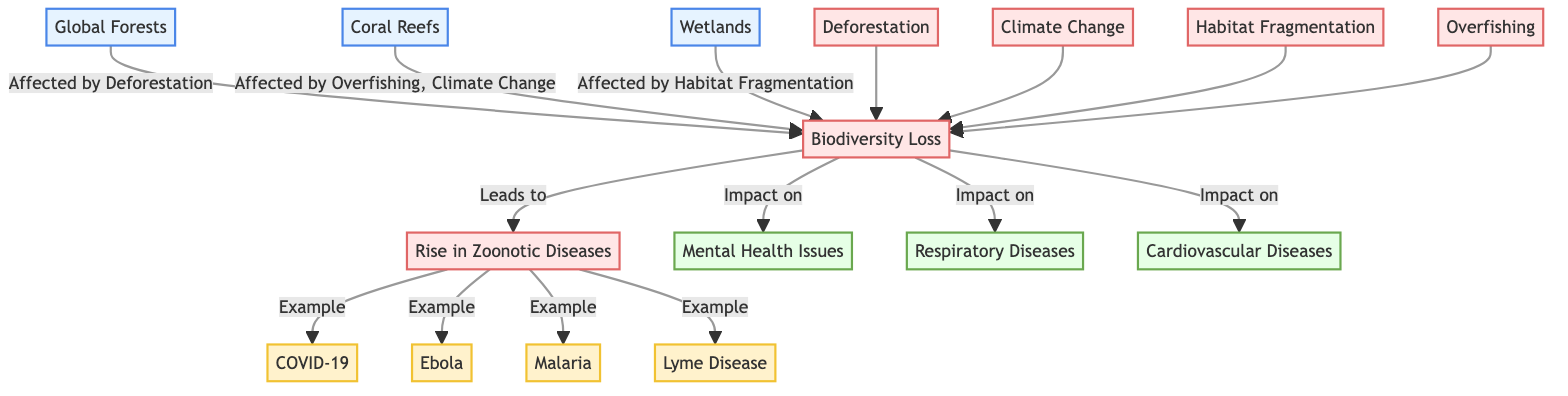What ecosystems are affected by deforestation? In the diagram, Global Forests is directly connected to Biodiversity Loss with the label "Affected by Deforestation". This indicates that Global Forests are one of the ecosystems impacted by deforestation.
Answer: Global Forests How many diseases are examples of zoonotic diseases in the diagram? The diagram lists four specific examples of zoonotic diseases connected to the Zoonotic Diseases node: COVID-19, Ebola, Malaria, and Lyme Disease. Counting these, we find there are four examples.
Answer: 4 Which ecosystem is affected by habitat fragmentation? The diagram shows a connection from Wetlands to Biodiversity Loss with the label "Affected by Habitat Fragmentation". This indicates that Wetlands is the ecosystem affected by habitat fragmentation.
Answer: Wetlands What is the impact of biodiversity loss on mental health? The diagram indicates a direct connection from Biodiversity Loss to Mental Health Issues with the label "Impact on". This shows that biodiversity loss has an effect on mental health.
Answer: Mental Health Issues Which disease is listed as an example of a zoonotic disease along with malaria? Among the list of zoonotic diseases shown in the diagram, alongside Malaria, the other examples include COVID-19, Ebola, and Lyme Disease. COVID-19 is specifically mentioned as an example next to Zoonotic Diseases.
Answer: COVID-19 How many threats lead to biodiversity loss in the diagram? The diagram illustrates five different threats that lead to biodiversity loss, including Deforestation, Climate Change, Habitat Fragmentation, Overfishing, and Biodiversity Loss that leads to Zoonotic Diseases. Counting these, the number is five.
Answer: 5 What are the specific types of diseases linked to biodiversity loss? The diagram directly connects Biodiversity Loss to three types of health impacts: Mental Health Issues, Respiratory Diseases, and Cardiovascular Diseases. This indicates that these three are the specific health impacts linked to biodiversity loss.
Answer: Mental Health Issues, Respiratory Diseases, Cardiovascular Diseases What is the connection between coral reefs and biodiversity loss? The diagram highlights that Coral Reefs are impacted by Overfishing and Climate Change, which leads to Biodiversity Loss. This shows the direct relationship between Coral Reefs and the resulting biodiversity loss due to these threats.
Answer: Overfishing, Climate Change 